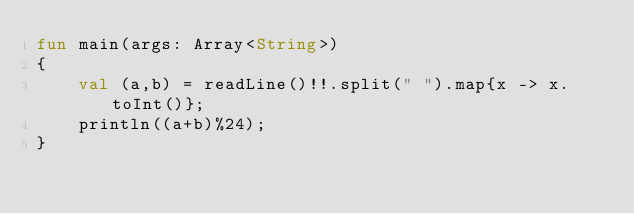Convert code to text. <code><loc_0><loc_0><loc_500><loc_500><_Kotlin_>fun main(args: Array<String>) 
{
    val (a,b) = readLine()!!.split(" ").map{x -> x.toInt()};
    println((a+b)%24);
}
</code> 